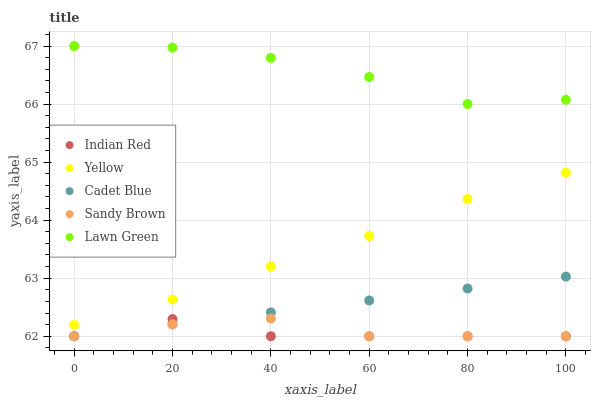Does Indian Red have the minimum area under the curve?
Answer yes or no. Yes. Does Lawn Green have the maximum area under the curve?
Answer yes or no. Yes. Does Cadet Blue have the minimum area under the curve?
Answer yes or no. No. Does Cadet Blue have the maximum area under the curve?
Answer yes or no. No. Is Cadet Blue the smoothest?
Answer yes or no. Yes. Is Lawn Green the roughest?
Answer yes or no. Yes. Is Sandy Brown the smoothest?
Answer yes or no. No. Is Sandy Brown the roughest?
Answer yes or no. No. Does Cadet Blue have the lowest value?
Answer yes or no. Yes. Does Yellow have the lowest value?
Answer yes or no. No. Does Lawn Green have the highest value?
Answer yes or no. Yes. Does Cadet Blue have the highest value?
Answer yes or no. No. Is Cadet Blue less than Lawn Green?
Answer yes or no. Yes. Is Lawn Green greater than Indian Red?
Answer yes or no. Yes. Does Sandy Brown intersect Indian Red?
Answer yes or no. Yes. Is Sandy Brown less than Indian Red?
Answer yes or no. No. Is Sandy Brown greater than Indian Red?
Answer yes or no. No. Does Cadet Blue intersect Lawn Green?
Answer yes or no. No. 